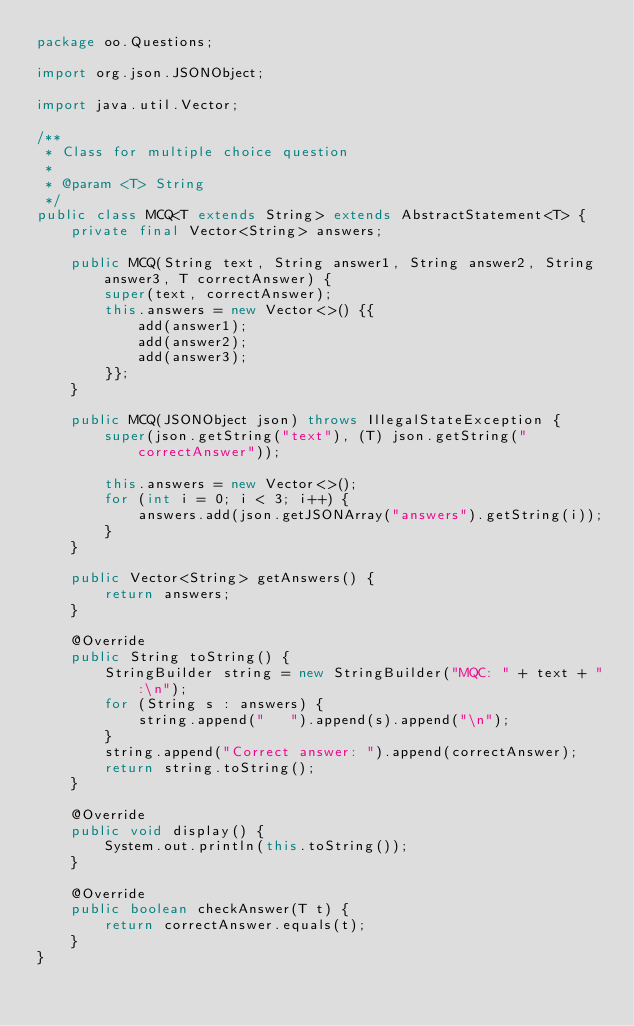<code> <loc_0><loc_0><loc_500><loc_500><_Java_>package oo.Questions;

import org.json.JSONObject;

import java.util.Vector;

/**
 * Class for multiple choice question
 *
 * @param <T> String
 */
public class MCQ<T extends String> extends AbstractStatement<T> {
    private final Vector<String> answers;

    public MCQ(String text, String answer1, String answer2, String answer3, T correctAnswer) {
        super(text, correctAnswer);
        this.answers = new Vector<>() {{
            add(answer1);
            add(answer2);
            add(answer3);
        }};
    }

    public MCQ(JSONObject json) throws IllegalStateException {
        super(json.getString("text"), (T) json.getString("correctAnswer"));

        this.answers = new Vector<>();
        for (int i = 0; i < 3; i++) {
            answers.add(json.getJSONArray("answers").getString(i));
        }
    }

    public Vector<String> getAnswers() {
        return answers;
    }

    @Override
    public String toString() {
        StringBuilder string = new StringBuilder("MQC: " + text + ":\n");
        for (String s : answers) {
            string.append("   ").append(s).append("\n");
        }
        string.append("Correct answer: ").append(correctAnswer);
        return string.toString();
    }

    @Override
    public void display() {
        System.out.println(this.toString());
    }

    @Override
    public boolean checkAnswer(T t) {
        return correctAnswer.equals(t);
    }
}
</code> 